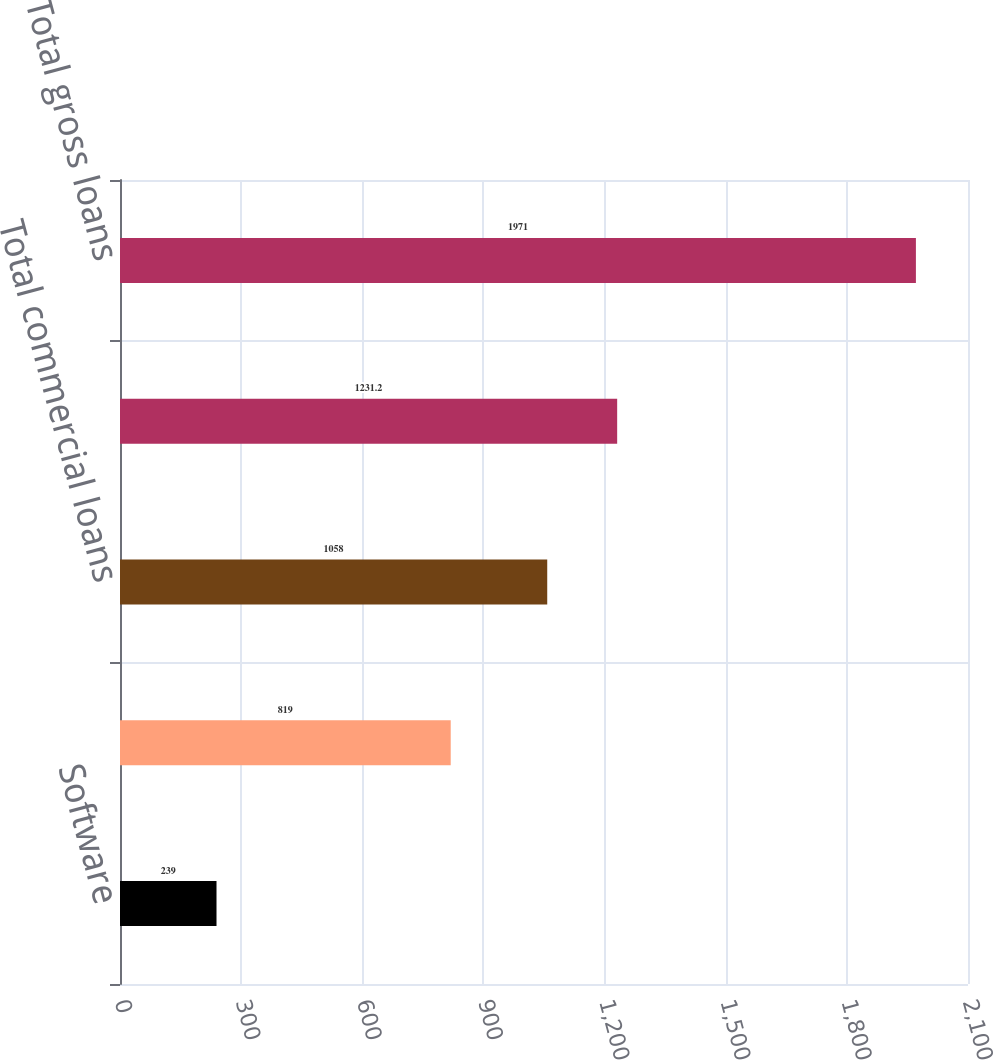Convert chart. <chart><loc_0><loc_0><loc_500><loc_500><bar_chart><fcel>Software<fcel>Hardware<fcel>Total commercial loans<fcel>Total gross loans excluding<fcel>Total gross loans<nl><fcel>239<fcel>819<fcel>1058<fcel>1231.2<fcel>1971<nl></chart> 